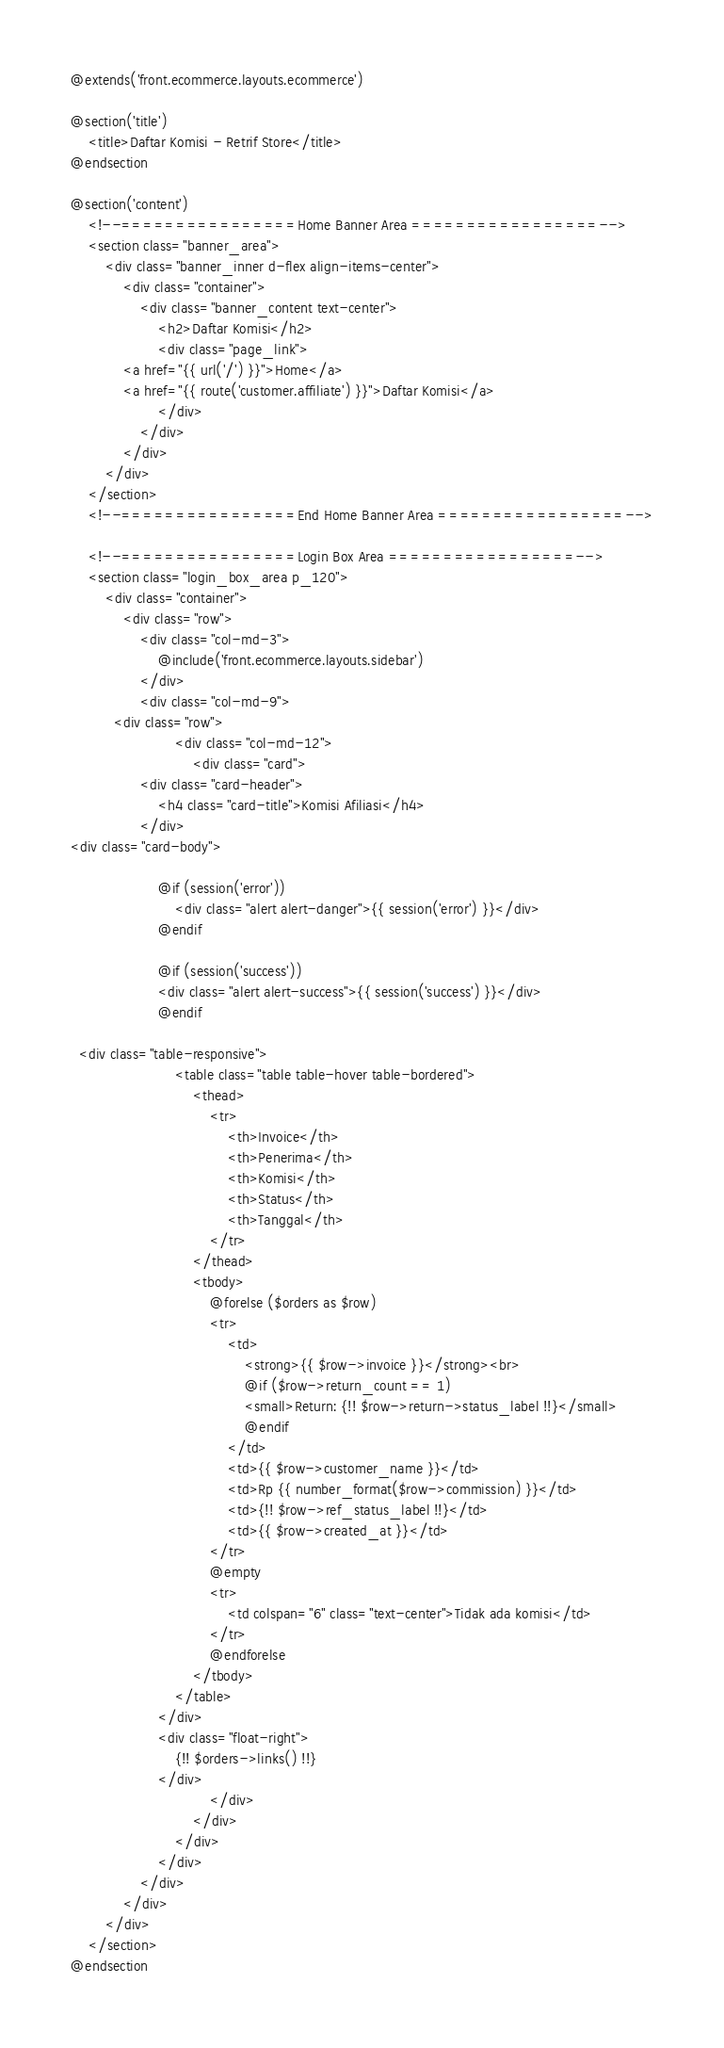<code> <loc_0><loc_0><loc_500><loc_500><_PHP_>@extends('front.ecommerce.layouts.ecommerce')

@section('title')
    <title>Daftar Komisi - Retrif Store</title>
@endsection

@section('content')
    <!--================Home Banner Area =================-->
	<section class="banner_area">
		<div class="banner_inner d-flex align-items-center">
			<div class="container">
				<div class="banner_content text-center">
					<h2>Daftar Komisi</h2>
					<div class="page_link">
            <a href="{{ url('/') }}">Home</a>
            <a href="{{ route('customer.affiliate') }}">Daftar Komisi</a>
					</div>
				</div>
			</div>
		</div>
	</section>
	<!--================End Home Banner Area =================-->

	<!--================Login Box Area =================-->
	<section class="login_box_area p_120">
		<div class="container">
			<div class="row">
				<div class="col-md-3">
					@include('front.ecommerce.layouts.sidebar')
				</div>
				<div class="col-md-9">
          <div class="row">
						<div class="col-md-12">
							<div class="card">
                <div class="card-header">
                    <h4 class="card-title">Komisi Afiliasi</h4>
                </div>
<div class="card-body">

                    @if (session('error'))
                        <div class="alert alert-danger">{{ session('error') }}</div>
                    @endif

                    @if (session('success'))
                    <div class="alert alert-success">{{ session('success') }}</div>
                    @endif

  <div class="table-responsive">
                        <table class="table table-hover table-bordered">
                            <thead>
                                <tr>
                                    <th>Invoice</th>
                                    <th>Penerima</th>
                                    <th>Komisi</th>
                                    <th>Status</th>
                                    <th>Tanggal</th>
                                </tr>
                            </thead>
                            <tbody>
                                @forelse ($orders as $row) 
                                <tr>
                                    <td>
                                        <strong>{{ $row->invoice }}</strong><br>
                                        @if ($row->return_count == 1)
                                        <small>Return: {!! $row->return->status_label !!}</small>
                                        @endif
                                    </td>
                                    <td>{{ $row->customer_name }}</td>
                                    <td>Rp {{ number_format($row->commission) }}</td>
                                    <td>{!! $row->ref_status_label !!}</td>
                                    <td>{{ $row->created_at }}</td>
                                </tr>
                                @empty
                                <tr>
                                    <td colspan="6" class="text-center">Tidak ada komisi</td>
                                </tr>
                                @endforelse
                            </tbody>
                        </table>
                    </div>
                    <div class="float-right">
                        {!! $orders->links() !!}
                    </div>
								</div>
							</div>
						</div>
					</div>
				</div>
			</div>
		</div>
	</section>
@endsection</code> 